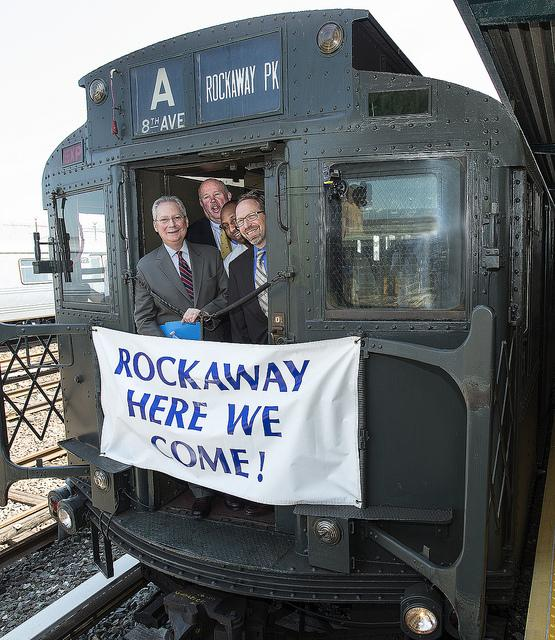Where is this train heading? rockaway 